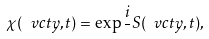Convert formula to latex. <formula><loc_0><loc_0><loc_500><loc_500>\chi ( \ v c t y , t ) = \exp { \frac { i } { } S ( \ v c t y , t ) } ,</formula> 